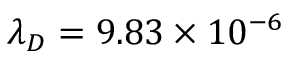Convert formula to latex. <formula><loc_0><loc_0><loc_500><loc_500>{ \lambda } _ { D } = 9 . 8 3 \times 1 0 ^ { - 6 }</formula> 